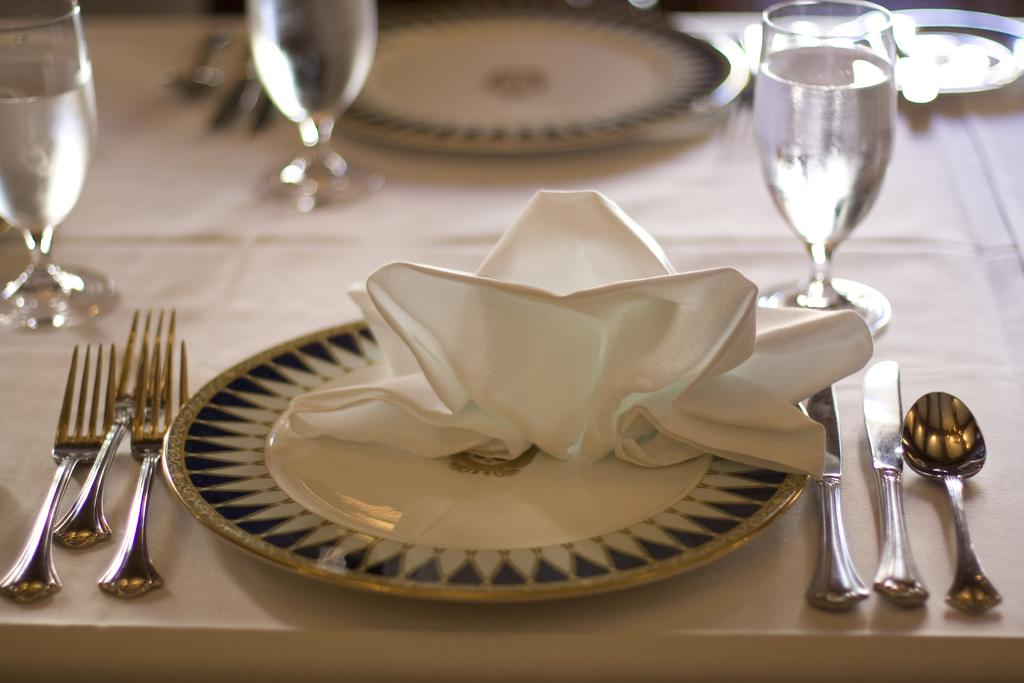How many plates are visible in the image? There are two plates in the image. Where are the forks located in the image? The forks are on the left side of the image. What utensils are on the right side of the image? There is a knife and a spoon on the right side of the image. What is in the glasses in the image? The glasses contain water in the image. What type of sign can be seen on the plate in the image? There is no sign present on the plate in the image. What verse is written on the fork in the image? There is no verse written on the fork in the image; it is a utensil for eating. 